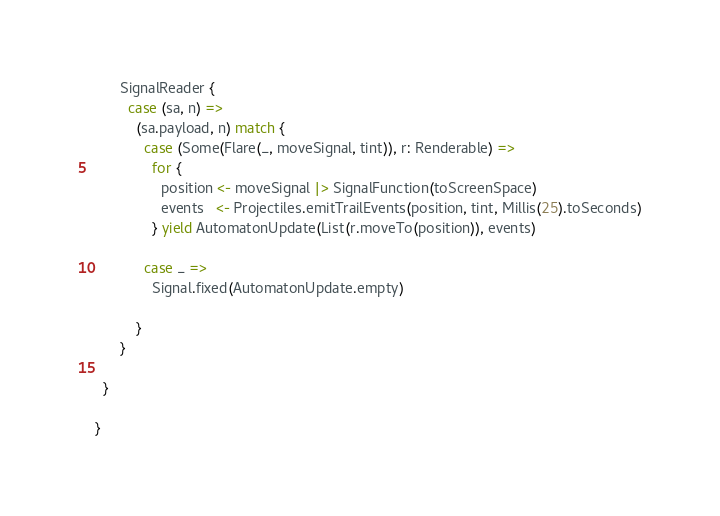<code> <loc_0><loc_0><loc_500><loc_500><_Scala_>      SignalReader {
        case (sa, n) =>
          (sa.payload, n) match {
            case (Some(Flare(_, moveSignal, tint)), r: Renderable) =>
              for {
                position <- moveSignal |> SignalFunction(toScreenSpace)
                events   <- Projectiles.emitTrailEvents(position, tint, Millis(25).toSeconds)
              } yield AutomatonUpdate(List(r.moveTo(position)), events)

            case _ =>
              Signal.fixed(AutomatonUpdate.empty)

          }
      }

  }

}
</code> 